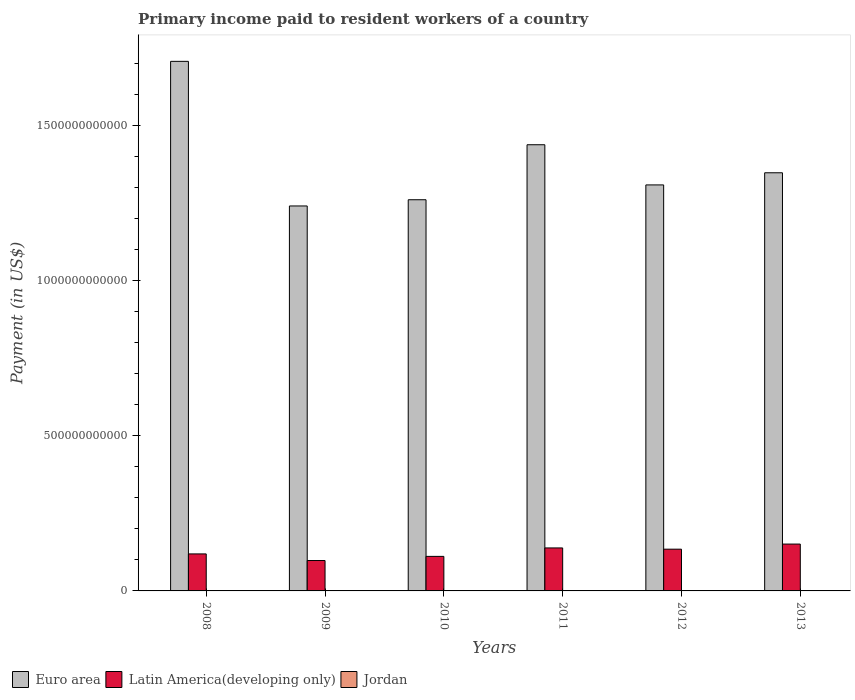Are the number of bars per tick equal to the number of legend labels?
Give a very brief answer. Yes. Are the number of bars on each tick of the X-axis equal?
Your response must be concise. Yes. How many bars are there on the 5th tick from the left?
Give a very brief answer. 3. How many bars are there on the 1st tick from the right?
Ensure brevity in your answer.  3. What is the label of the 4th group of bars from the left?
Offer a terse response. 2011. What is the amount paid to workers in Latin America(developing only) in 2008?
Your response must be concise. 1.19e+11. Across all years, what is the maximum amount paid to workers in Euro area?
Your answer should be very brief. 1.71e+12. Across all years, what is the minimum amount paid to workers in Jordan?
Offer a terse response. 5.85e+08. In which year was the amount paid to workers in Jordan minimum?
Offer a very short reply. 2009. What is the total amount paid to workers in Euro area in the graph?
Your answer should be compact. 8.30e+12. What is the difference between the amount paid to workers in Euro area in 2010 and that in 2013?
Offer a very short reply. -8.68e+1. What is the difference between the amount paid to workers in Latin America(developing only) in 2011 and the amount paid to workers in Euro area in 2009?
Provide a short and direct response. -1.10e+12. What is the average amount paid to workers in Euro area per year?
Provide a succinct answer. 1.38e+12. In the year 2011, what is the difference between the amount paid to workers in Jordan and amount paid to workers in Latin America(developing only)?
Your response must be concise. -1.37e+11. In how many years, is the amount paid to workers in Euro area greater than 1000000000000 US$?
Make the answer very short. 6. What is the ratio of the amount paid to workers in Jordan in 2010 to that in 2011?
Your answer should be compact. 1.13. Is the amount paid to workers in Euro area in 2009 less than that in 2010?
Make the answer very short. Yes. Is the difference between the amount paid to workers in Jordan in 2009 and 2010 greater than the difference between the amount paid to workers in Latin America(developing only) in 2009 and 2010?
Keep it short and to the point. Yes. What is the difference between the highest and the second highest amount paid to workers in Euro area?
Your answer should be compact. 2.69e+11. What is the difference between the highest and the lowest amount paid to workers in Jordan?
Give a very brief answer. 5.47e+08. Is the sum of the amount paid to workers in Latin America(developing only) in 2010 and 2013 greater than the maximum amount paid to workers in Jordan across all years?
Offer a very short reply. Yes. What does the 3rd bar from the left in 2013 represents?
Give a very brief answer. Jordan. What does the 1st bar from the right in 2010 represents?
Your answer should be compact. Jordan. How many bars are there?
Give a very brief answer. 18. How many years are there in the graph?
Give a very brief answer. 6. What is the difference between two consecutive major ticks on the Y-axis?
Ensure brevity in your answer.  5.00e+11. How many legend labels are there?
Provide a succinct answer. 3. What is the title of the graph?
Offer a very short reply. Primary income paid to resident workers of a country. Does "Cambodia" appear as one of the legend labels in the graph?
Your answer should be compact. No. What is the label or title of the X-axis?
Provide a succinct answer. Years. What is the label or title of the Y-axis?
Give a very brief answer. Payment (in US$). What is the Payment (in US$) of Euro area in 2008?
Offer a terse response. 1.71e+12. What is the Payment (in US$) of Latin America(developing only) in 2008?
Your response must be concise. 1.19e+11. What is the Payment (in US$) in Jordan in 2008?
Your answer should be compact. 6.40e+08. What is the Payment (in US$) of Euro area in 2009?
Provide a short and direct response. 1.24e+12. What is the Payment (in US$) in Latin America(developing only) in 2009?
Make the answer very short. 9.79e+1. What is the Payment (in US$) in Jordan in 2009?
Offer a very short reply. 5.85e+08. What is the Payment (in US$) in Euro area in 2010?
Make the answer very short. 1.26e+12. What is the Payment (in US$) in Latin America(developing only) in 2010?
Provide a succinct answer. 1.11e+11. What is the Payment (in US$) of Jordan in 2010?
Your answer should be compact. 1.10e+09. What is the Payment (in US$) of Euro area in 2011?
Your response must be concise. 1.44e+12. What is the Payment (in US$) of Latin America(developing only) in 2011?
Your answer should be very brief. 1.38e+11. What is the Payment (in US$) of Jordan in 2011?
Offer a very short reply. 9.75e+08. What is the Payment (in US$) of Euro area in 2012?
Your answer should be compact. 1.31e+12. What is the Payment (in US$) in Latin America(developing only) in 2012?
Ensure brevity in your answer.  1.34e+11. What is the Payment (in US$) of Jordan in 2012?
Make the answer very short. 1.08e+09. What is the Payment (in US$) in Euro area in 2013?
Ensure brevity in your answer.  1.35e+12. What is the Payment (in US$) of Latin America(developing only) in 2013?
Give a very brief answer. 1.51e+11. What is the Payment (in US$) in Jordan in 2013?
Offer a terse response. 1.13e+09. Across all years, what is the maximum Payment (in US$) of Euro area?
Provide a short and direct response. 1.71e+12. Across all years, what is the maximum Payment (in US$) in Latin America(developing only)?
Your answer should be compact. 1.51e+11. Across all years, what is the maximum Payment (in US$) of Jordan?
Keep it short and to the point. 1.13e+09. Across all years, what is the minimum Payment (in US$) of Euro area?
Ensure brevity in your answer.  1.24e+12. Across all years, what is the minimum Payment (in US$) in Latin America(developing only)?
Your answer should be compact. 9.79e+1. Across all years, what is the minimum Payment (in US$) in Jordan?
Give a very brief answer. 5.85e+08. What is the total Payment (in US$) in Euro area in the graph?
Offer a terse response. 8.30e+12. What is the total Payment (in US$) of Latin America(developing only) in the graph?
Provide a short and direct response. 7.52e+11. What is the total Payment (in US$) of Jordan in the graph?
Offer a very short reply. 5.51e+09. What is the difference between the Payment (in US$) of Euro area in 2008 and that in 2009?
Offer a terse response. 4.66e+11. What is the difference between the Payment (in US$) of Latin America(developing only) in 2008 and that in 2009?
Keep it short and to the point. 2.13e+1. What is the difference between the Payment (in US$) in Jordan in 2008 and that in 2009?
Ensure brevity in your answer.  5.49e+07. What is the difference between the Payment (in US$) in Euro area in 2008 and that in 2010?
Provide a short and direct response. 4.46e+11. What is the difference between the Payment (in US$) of Latin America(developing only) in 2008 and that in 2010?
Offer a very short reply. 7.94e+09. What is the difference between the Payment (in US$) of Jordan in 2008 and that in 2010?
Make the answer very short. -4.62e+08. What is the difference between the Payment (in US$) in Euro area in 2008 and that in 2011?
Give a very brief answer. 2.69e+11. What is the difference between the Payment (in US$) of Latin America(developing only) in 2008 and that in 2011?
Your response must be concise. -1.92e+1. What is the difference between the Payment (in US$) of Jordan in 2008 and that in 2011?
Keep it short and to the point. -3.35e+08. What is the difference between the Payment (in US$) of Euro area in 2008 and that in 2012?
Offer a very short reply. 3.98e+11. What is the difference between the Payment (in US$) of Latin America(developing only) in 2008 and that in 2012?
Your response must be concise. -1.53e+1. What is the difference between the Payment (in US$) in Jordan in 2008 and that in 2012?
Your answer should be compact. -4.38e+08. What is the difference between the Payment (in US$) in Euro area in 2008 and that in 2013?
Keep it short and to the point. 3.59e+11. What is the difference between the Payment (in US$) of Latin America(developing only) in 2008 and that in 2013?
Ensure brevity in your answer.  -3.17e+1. What is the difference between the Payment (in US$) in Jordan in 2008 and that in 2013?
Offer a very short reply. -4.92e+08. What is the difference between the Payment (in US$) in Euro area in 2009 and that in 2010?
Your response must be concise. -2.00e+1. What is the difference between the Payment (in US$) of Latin America(developing only) in 2009 and that in 2010?
Keep it short and to the point. -1.33e+1. What is the difference between the Payment (in US$) in Jordan in 2009 and that in 2010?
Make the answer very short. -5.17e+08. What is the difference between the Payment (in US$) in Euro area in 2009 and that in 2011?
Give a very brief answer. -1.97e+11. What is the difference between the Payment (in US$) of Latin America(developing only) in 2009 and that in 2011?
Your answer should be very brief. -4.05e+1. What is the difference between the Payment (in US$) of Jordan in 2009 and that in 2011?
Give a very brief answer. -3.90e+08. What is the difference between the Payment (in US$) in Euro area in 2009 and that in 2012?
Offer a very short reply. -6.78e+1. What is the difference between the Payment (in US$) of Latin America(developing only) in 2009 and that in 2012?
Offer a very short reply. -3.65e+1. What is the difference between the Payment (in US$) of Jordan in 2009 and that in 2012?
Offer a terse response. -4.93e+08. What is the difference between the Payment (in US$) in Euro area in 2009 and that in 2013?
Provide a succinct answer. -1.07e+11. What is the difference between the Payment (in US$) of Latin America(developing only) in 2009 and that in 2013?
Provide a succinct answer. -5.30e+1. What is the difference between the Payment (in US$) in Jordan in 2009 and that in 2013?
Provide a short and direct response. -5.47e+08. What is the difference between the Payment (in US$) in Euro area in 2010 and that in 2011?
Your response must be concise. -1.77e+11. What is the difference between the Payment (in US$) of Latin America(developing only) in 2010 and that in 2011?
Ensure brevity in your answer.  -2.72e+1. What is the difference between the Payment (in US$) in Jordan in 2010 and that in 2011?
Make the answer very short. 1.27e+08. What is the difference between the Payment (in US$) of Euro area in 2010 and that in 2012?
Your answer should be compact. -4.78e+1. What is the difference between the Payment (in US$) of Latin America(developing only) in 2010 and that in 2012?
Make the answer very short. -2.32e+1. What is the difference between the Payment (in US$) of Jordan in 2010 and that in 2012?
Offer a very short reply. 2.36e+07. What is the difference between the Payment (in US$) in Euro area in 2010 and that in 2013?
Your answer should be compact. -8.68e+1. What is the difference between the Payment (in US$) in Latin America(developing only) in 2010 and that in 2013?
Provide a short and direct response. -3.97e+1. What is the difference between the Payment (in US$) of Jordan in 2010 and that in 2013?
Give a very brief answer. -3.06e+07. What is the difference between the Payment (in US$) in Euro area in 2011 and that in 2012?
Ensure brevity in your answer.  1.29e+11. What is the difference between the Payment (in US$) in Latin America(developing only) in 2011 and that in 2012?
Make the answer very short. 3.99e+09. What is the difference between the Payment (in US$) of Jordan in 2011 and that in 2012?
Offer a very short reply. -1.03e+08. What is the difference between the Payment (in US$) of Euro area in 2011 and that in 2013?
Your answer should be compact. 9.03e+1. What is the difference between the Payment (in US$) of Latin America(developing only) in 2011 and that in 2013?
Offer a terse response. -1.25e+1. What is the difference between the Payment (in US$) in Jordan in 2011 and that in 2013?
Offer a very short reply. -1.57e+08. What is the difference between the Payment (in US$) of Euro area in 2012 and that in 2013?
Offer a very short reply. -3.91e+1. What is the difference between the Payment (in US$) in Latin America(developing only) in 2012 and that in 2013?
Provide a succinct answer. -1.65e+1. What is the difference between the Payment (in US$) in Jordan in 2012 and that in 2013?
Keep it short and to the point. -5.42e+07. What is the difference between the Payment (in US$) in Euro area in 2008 and the Payment (in US$) in Latin America(developing only) in 2009?
Your response must be concise. 1.61e+12. What is the difference between the Payment (in US$) in Euro area in 2008 and the Payment (in US$) in Jordan in 2009?
Provide a succinct answer. 1.70e+12. What is the difference between the Payment (in US$) of Latin America(developing only) in 2008 and the Payment (in US$) of Jordan in 2009?
Your response must be concise. 1.19e+11. What is the difference between the Payment (in US$) in Euro area in 2008 and the Payment (in US$) in Latin America(developing only) in 2010?
Ensure brevity in your answer.  1.59e+12. What is the difference between the Payment (in US$) in Euro area in 2008 and the Payment (in US$) in Jordan in 2010?
Provide a succinct answer. 1.70e+12. What is the difference between the Payment (in US$) of Latin America(developing only) in 2008 and the Payment (in US$) of Jordan in 2010?
Provide a succinct answer. 1.18e+11. What is the difference between the Payment (in US$) in Euro area in 2008 and the Payment (in US$) in Latin America(developing only) in 2011?
Offer a very short reply. 1.57e+12. What is the difference between the Payment (in US$) of Euro area in 2008 and the Payment (in US$) of Jordan in 2011?
Provide a short and direct response. 1.70e+12. What is the difference between the Payment (in US$) in Latin America(developing only) in 2008 and the Payment (in US$) in Jordan in 2011?
Provide a succinct answer. 1.18e+11. What is the difference between the Payment (in US$) in Euro area in 2008 and the Payment (in US$) in Latin America(developing only) in 2012?
Provide a succinct answer. 1.57e+12. What is the difference between the Payment (in US$) of Euro area in 2008 and the Payment (in US$) of Jordan in 2012?
Offer a terse response. 1.70e+12. What is the difference between the Payment (in US$) in Latin America(developing only) in 2008 and the Payment (in US$) in Jordan in 2012?
Provide a short and direct response. 1.18e+11. What is the difference between the Payment (in US$) of Euro area in 2008 and the Payment (in US$) of Latin America(developing only) in 2013?
Make the answer very short. 1.55e+12. What is the difference between the Payment (in US$) in Euro area in 2008 and the Payment (in US$) in Jordan in 2013?
Your answer should be compact. 1.70e+12. What is the difference between the Payment (in US$) in Latin America(developing only) in 2008 and the Payment (in US$) in Jordan in 2013?
Ensure brevity in your answer.  1.18e+11. What is the difference between the Payment (in US$) in Euro area in 2009 and the Payment (in US$) in Latin America(developing only) in 2010?
Provide a succinct answer. 1.13e+12. What is the difference between the Payment (in US$) in Euro area in 2009 and the Payment (in US$) in Jordan in 2010?
Offer a very short reply. 1.24e+12. What is the difference between the Payment (in US$) in Latin America(developing only) in 2009 and the Payment (in US$) in Jordan in 2010?
Provide a succinct answer. 9.68e+1. What is the difference between the Payment (in US$) of Euro area in 2009 and the Payment (in US$) of Latin America(developing only) in 2011?
Offer a terse response. 1.10e+12. What is the difference between the Payment (in US$) in Euro area in 2009 and the Payment (in US$) in Jordan in 2011?
Offer a very short reply. 1.24e+12. What is the difference between the Payment (in US$) in Latin America(developing only) in 2009 and the Payment (in US$) in Jordan in 2011?
Provide a succinct answer. 9.69e+1. What is the difference between the Payment (in US$) in Euro area in 2009 and the Payment (in US$) in Latin America(developing only) in 2012?
Keep it short and to the point. 1.11e+12. What is the difference between the Payment (in US$) in Euro area in 2009 and the Payment (in US$) in Jordan in 2012?
Ensure brevity in your answer.  1.24e+12. What is the difference between the Payment (in US$) of Latin America(developing only) in 2009 and the Payment (in US$) of Jordan in 2012?
Provide a succinct answer. 9.68e+1. What is the difference between the Payment (in US$) of Euro area in 2009 and the Payment (in US$) of Latin America(developing only) in 2013?
Offer a very short reply. 1.09e+12. What is the difference between the Payment (in US$) in Euro area in 2009 and the Payment (in US$) in Jordan in 2013?
Ensure brevity in your answer.  1.24e+12. What is the difference between the Payment (in US$) in Latin America(developing only) in 2009 and the Payment (in US$) in Jordan in 2013?
Keep it short and to the point. 9.68e+1. What is the difference between the Payment (in US$) of Euro area in 2010 and the Payment (in US$) of Latin America(developing only) in 2011?
Offer a terse response. 1.12e+12. What is the difference between the Payment (in US$) of Euro area in 2010 and the Payment (in US$) of Jordan in 2011?
Your response must be concise. 1.26e+12. What is the difference between the Payment (in US$) of Latin America(developing only) in 2010 and the Payment (in US$) of Jordan in 2011?
Your answer should be very brief. 1.10e+11. What is the difference between the Payment (in US$) in Euro area in 2010 and the Payment (in US$) in Latin America(developing only) in 2012?
Provide a succinct answer. 1.13e+12. What is the difference between the Payment (in US$) of Euro area in 2010 and the Payment (in US$) of Jordan in 2012?
Provide a succinct answer. 1.26e+12. What is the difference between the Payment (in US$) in Latin America(developing only) in 2010 and the Payment (in US$) in Jordan in 2012?
Make the answer very short. 1.10e+11. What is the difference between the Payment (in US$) in Euro area in 2010 and the Payment (in US$) in Latin America(developing only) in 2013?
Your answer should be compact. 1.11e+12. What is the difference between the Payment (in US$) in Euro area in 2010 and the Payment (in US$) in Jordan in 2013?
Offer a very short reply. 1.26e+12. What is the difference between the Payment (in US$) of Latin America(developing only) in 2010 and the Payment (in US$) of Jordan in 2013?
Your answer should be compact. 1.10e+11. What is the difference between the Payment (in US$) in Euro area in 2011 and the Payment (in US$) in Latin America(developing only) in 2012?
Give a very brief answer. 1.30e+12. What is the difference between the Payment (in US$) of Euro area in 2011 and the Payment (in US$) of Jordan in 2012?
Ensure brevity in your answer.  1.44e+12. What is the difference between the Payment (in US$) in Latin America(developing only) in 2011 and the Payment (in US$) in Jordan in 2012?
Give a very brief answer. 1.37e+11. What is the difference between the Payment (in US$) of Euro area in 2011 and the Payment (in US$) of Latin America(developing only) in 2013?
Your answer should be compact. 1.29e+12. What is the difference between the Payment (in US$) of Euro area in 2011 and the Payment (in US$) of Jordan in 2013?
Provide a succinct answer. 1.44e+12. What is the difference between the Payment (in US$) in Latin America(developing only) in 2011 and the Payment (in US$) in Jordan in 2013?
Your answer should be compact. 1.37e+11. What is the difference between the Payment (in US$) in Euro area in 2012 and the Payment (in US$) in Latin America(developing only) in 2013?
Offer a terse response. 1.16e+12. What is the difference between the Payment (in US$) of Euro area in 2012 and the Payment (in US$) of Jordan in 2013?
Keep it short and to the point. 1.31e+12. What is the difference between the Payment (in US$) in Latin America(developing only) in 2012 and the Payment (in US$) in Jordan in 2013?
Offer a terse response. 1.33e+11. What is the average Payment (in US$) of Euro area per year?
Your response must be concise. 1.38e+12. What is the average Payment (in US$) in Latin America(developing only) per year?
Keep it short and to the point. 1.25e+11. What is the average Payment (in US$) of Jordan per year?
Offer a terse response. 9.19e+08. In the year 2008, what is the difference between the Payment (in US$) of Euro area and Payment (in US$) of Latin America(developing only)?
Your response must be concise. 1.59e+12. In the year 2008, what is the difference between the Payment (in US$) in Euro area and Payment (in US$) in Jordan?
Your answer should be compact. 1.70e+12. In the year 2008, what is the difference between the Payment (in US$) of Latin America(developing only) and Payment (in US$) of Jordan?
Provide a short and direct response. 1.19e+11. In the year 2009, what is the difference between the Payment (in US$) of Euro area and Payment (in US$) of Latin America(developing only)?
Provide a succinct answer. 1.14e+12. In the year 2009, what is the difference between the Payment (in US$) of Euro area and Payment (in US$) of Jordan?
Make the answer very short. 1.24e+12. In the year 2009, what is the difference between the Payment (in US$) of Latin America(developing only) and Payment (in US$) of Jordan?
Provide a succinct answer. 9.73e+1. In the year 2010, what is the difference between the Payment (in US$) of Euro area and Payment (in US$) of Latin America(developing only)?
Offer a terse response. 1.15e+12. In the year 2010, what is the difference between the Payment (in US$) of Euro area and Payment (in US$) of Jordan?
Your response must be concise. 1.26e+12. In the year 2010, what is the difference between the Payment (in US$) of Latin America(developing only) and Payment (in US$) of Jordan?
Make the answer very short. 1.10e+11. In the year 2011, what is the difference between the Payment (in US$) of Euro area and Payment (in US$) of Latin America(developing only)?
Your answer should be compact. 1.30e+12. In the year 2011, what is the difference between the Payment (in US$) in Euro area and Payment (in US$) in Jordan?
Ensure brevity in your answer.  1.44e+12. In the year 2011, what is the difference between the Payment (in US$) of Latin America(developing only) and Payment (in US$) of Jordan?
Your answer should be compact. 1.37e+11. In the year 2012, what is the difference between the Payment (in US$) in Euro area and Payment (in US$) in Latin America(developing only)?
Provide a short and direct response. 1.17e+12. In the year 2012, what is the difference between the Payment (in US$) in Euro area and Payment (in US$) in Jordan?
Offer a terse response. 1.31e+12. In the year 2012, what is the difference between the Payment (in US$) of Latin America(developing only) and Payment (in US$) of Jordan?
Offer a very short reply. 1.33e+11. In the year 2013, what is the difference between the Payment (in US$) in Euro area and Payment (in US$) in Latin America(developing only)?
Your answer should be compact. 1.20e+12. In the year 2013, what is the difference between the Payment (in US$) in Euro area and Payment (in US$) in Jordan?
Your answer should be very brief. 1.35e+12. In the year 2013, what is the difference between the Payment (in US$) of Latin America(developing only) and Payment (in US$) of Jordan?
Offer a terse response. 1.50e+11. What is the ratio of the Payment (in US$) in Euro area in 2008 to that in 2009?
Offer a very short reply. 1.38. What is the ratio of the Payment (in US$) of Latin America(developing only) in 2008 to that in 2009?
Make the answer very short. 1.22. What is the ratio of the Payment (in US$) of Jordan in 2008 to that in 2009?
Give a very brief answer. 1.09. What is the ratio of the Payment (in US$) of Euro area in 2008 to that in 2010?
Your answer should be compact. 1.35. What is the ratio of the Payment (in US$) of Latin America(developing only) in 2008 to that in 2010?
Your response must be concise. 1.07. What is the ratio of the Payment (in US$) in Jordan in 2008 to that in 2010?
Ensure brevity in your answer.  0.58. What is the ratio of the Payment (in US$) in Euro area in 2008 to that in 2011?
Offer a very short reply. 1.19. What is the ratio of the Payment (in US$) in Latin America(developing only) in 2008 to that in 2011?
Provide a succinct answer. 0.86. What is the ratio of the Payment (in US$) in Jordan in 2008 to that in 2011?
Provide a succinct answer. 0.66. What is the ratio of the Payment (in US$) of Euro area in 2008 to that in 2012?
Your answer should be very brief. 1.3. What is the ratio of the Payment (in US$) in Latin America(developing only) in 2008 to that in 2012?
Give a very brief answer. 0.89. What is the ratio of the Payment (in US$) in Jordan in 2008 to that in 2012?
Provide a short and direct response. 0.59. What is the ratio of the Payment (in US$) of Euro area in 2008 to that in 2013?
Keep it short and to the point. 1.27. What is the ratio of the Payment (in US$) of Latin America(developing only) in 2008 to that in 2013?
Your answer should be compact. 0.79. What is the ratio of the Payment (in US$) of Jordan in 2008 to that in 2013?
Make the answer very short. 0.57. What is the ratio of the Payment (in US$) in Euro area in 2009 to that in 2010?
Provide a short and direct response. 0.98. What is the ratio of the Payment (in US$) of Latin America(developing only) in 2009 to that in 2010?
Provide a short and direct response. 0.88. What is the ratio of the Payment (in US$) in Jordan in 2009 to that in 2010?
Ensure brevity in your answer.  0.53. What is the ratio of the Payment (in US$) of Euro area in 2009 to that in 2011?
Ensure brevity in your answer.  0.86. What is the ratio of the Payment (in US$) of Latin America(developing only) in 2009 to that in 2011?
Provide a succinct answer. 0.71. What is the ratio of the Payment (in US$) of Jordan in 2009 to that in 2011?
Make the answer very short. 0.6. What is the ratio of the Payment (in US$) in Euro area in 2009 to that in 2012?
Your answer should be compact. 0.95. What is the ratio of the Payment (in US$) in Latin America(developing only) in 2009 to that in 2012?
Offer a very short reply. 0.73. What is the ratio of the Payment (in US$) in Jordan in 2009 to that in 2012?
Provide a short and direct response. 0.54. What is the ratio of the Payment (in US$) of Euro area in 2009 to that in 2013?
Your response must be concise. 0.92. What is the ratio of the Payment (in US$) in Latin America(developing only) in 2009 to that in 2013?
Provide a short and direct response. 0.65. What is the ratio of the Payment (in US$) of Jordan in 2009 to that in 2013?
Make the answer very short. 0.52. What is the ratio of the Payment (in US$) of Euro area in 2010 to that in 2011?
Provide a short and direct response. 0.88. What is the ratio of the Payment (in US$) in Latin America(developing only) in 2010 to that in 2011?
Keep it short and to the point. 0.8. What is the ratio of the Payment (in US$) in Jordan in 2010 to that in 2011?
Your answer should be compact. 1.13. What is the ratio of the Payment (in US$) in Euro area in 2010 to that in 2012?
Offer a very short reply. 0.96. What is the ratio of the Payment (in US$) in Latin America(developing only) in 2010 to that in 2012?
Provide a succinct answer. 0.83. What is the ratio of the Payment (in US$) of Jordan in 2010 to that in 2012?
Offer a very short reply. 1.02. What is the ratio of the Payment (in US$) of Euro area in 2010 to that in 2013?
Make the answer very short. 0.94. What is the ratio of the Payment (in US$) in Latin America(developing only) in 2010 to that in 2013?
Make the answer very short. 0.74. What is the ratio of the Payment (in US$) in Jordan in 2010 to that in 2013?
Keep it short and to the point. 0.97. What is the ratio of the Payment (in US$) of Euro area in 2011 to that in 2012?
Your answer should be very brief. 1.1. What is the ratio of the Payment (in US$) in Latin America(developing only) in 2011 to that in 2012?
Your response must be concise. 1.03. What is the ratio of the Payment (in US$) in Jordan in 2011 to that in 2012?
Keep it short and to the point. 0.9. What is the ratio of the Payment (in US$) of Euro area in 2011 to that in 2013?
Your response must be concise. 1.07. What is the ratio of the Payment (in US$) in Latin America(developing only) in 2011 to that in 2013?
Ensure brevity in your answer.  0.92. What is the ratio of the Payment (in US$) in Jordan in 2011 to that in 2013?
Your response must be concise. 0.86. What is the ratio of the Payment (in US$) of Euro area in 2012 to that in 2013?
Your response must be concise. 0.97. What is the ratio of the Payment (in US$) in Latin America(developing only) in 2012 to that in 2013?
Your response must be concise. 0.89. What is the ratio of the Payment (in US$) of Jordan in 2012 to that in 2013?
Keep it short and to the point. 0.95. What is the difference between the highest and the second highest Payment (in US$) in Euro area?
Keep it short and to the point. 2.69e+11. What is the difference between the highest and the second highest Payment (in US$) in Latin America(developing only)?
Offer a very short reply. 1.25e+1. What is the difference between the highest and the second highest Payment (in US$) of Jordan?
Your answer should be compact. 3.06e+07. What is the difference between the highest and the lowest Payment (in US$) in Euro area?
Keep it short and to the point. 4.66e+11. What is the difference between the highest and the lowest Payment (in US$) in Latin America(developing only)?
Make the answer very short. 5.30e+1. What is the difference between the highest and the lowest Payment (in US$) in Jordan?
Offer a very short reply. 5.47e+08. 